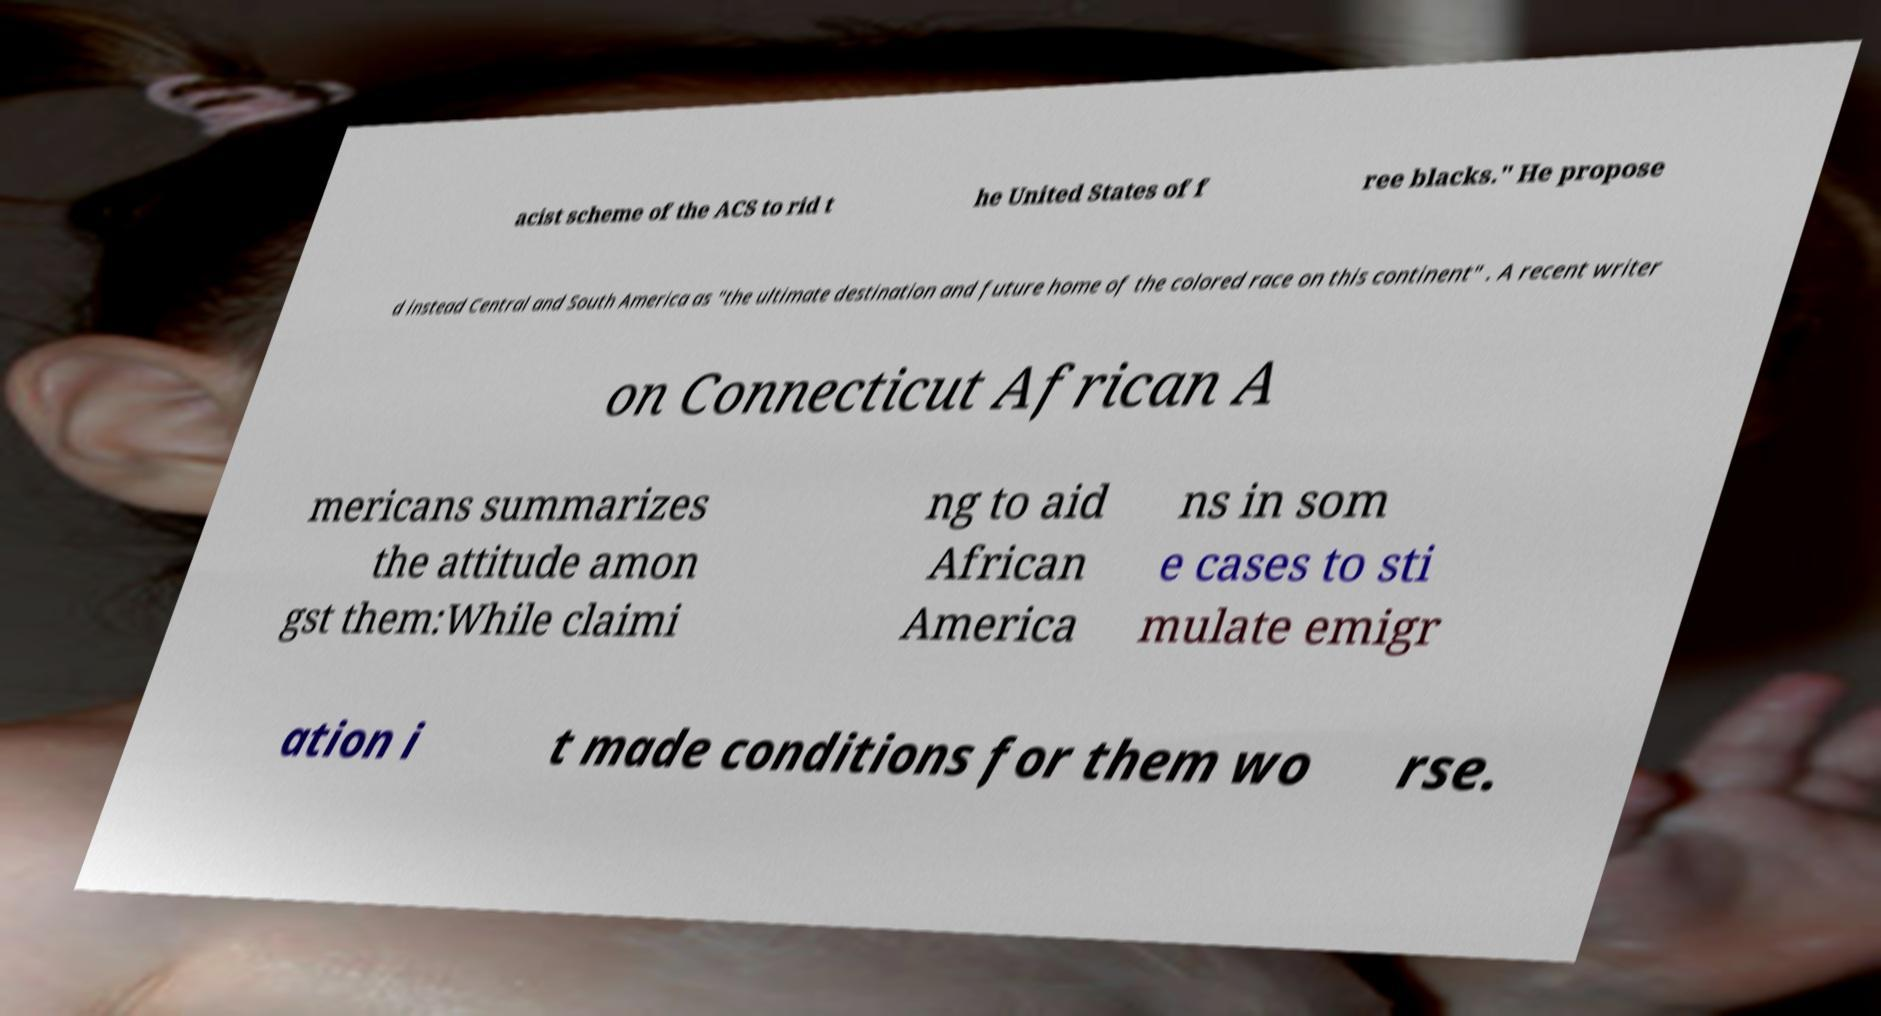There's text embedded in this image that I need extracted. Can you transcribe it verbatim? acist scheme of the ACS to rid t he United States of f ree blacks." He propose d instead Central and South America as "the ultimate destination and future home of the colored race on this continent" . A recent writer on Connecticut African A mericans summarizes the attitude amon gst them:While claimi ng to aid African America ns in som e cases to sti mulate emigr ation i t made conditions for them wo rse. 